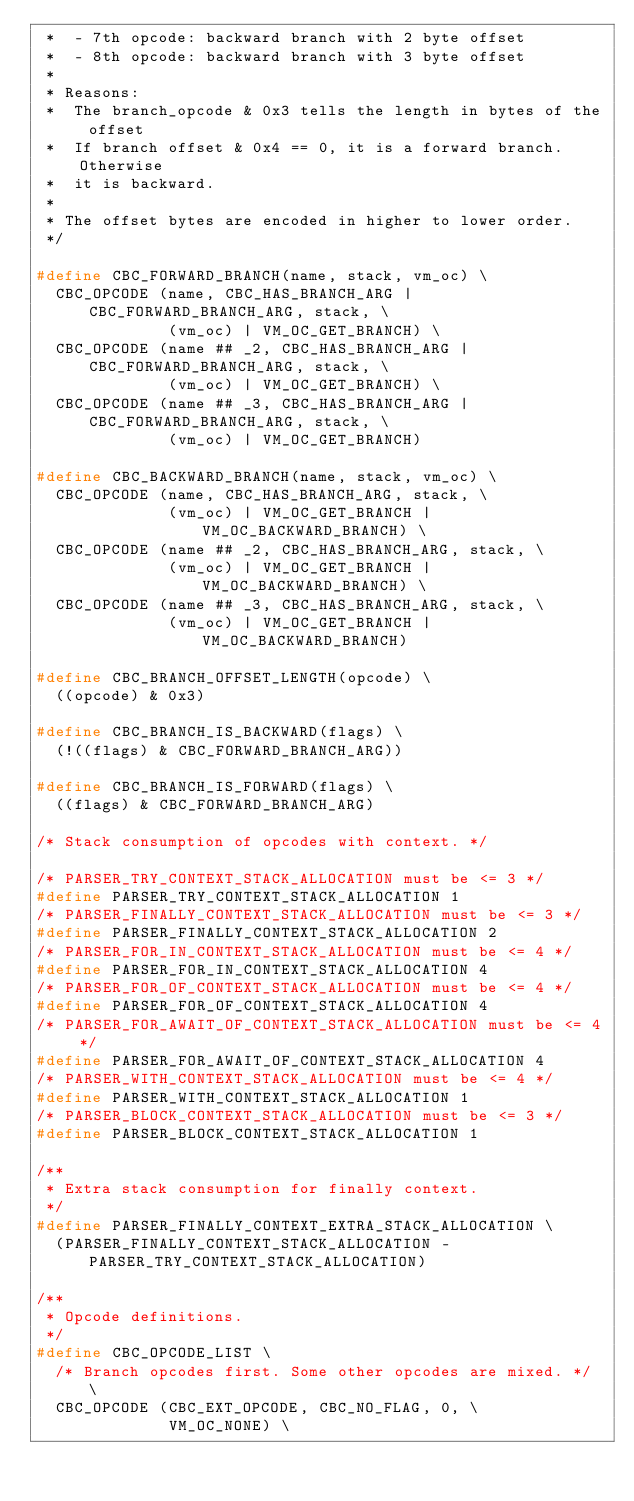<code> <loc_0><loc_0><loc_500><loc_500><_C_> *  - 7th opcode: backward branch with 2 byte offset
 *  - 8th opcode: backward branch with 3 byte offset
 *
 * Reasons:
 *  The branch_opcode & 0x3 tells the length in bytes of the offset
 *  If branch offset & 0x4 == 0, it is a forward branch. Otherwise
 *  it is backward.
 *
 * The offset bytes are encoded in higher to lower order.
 */

#define CBC_FORWARD_BRANCH(name, stack, vm_oc) \
  CBC_OPCODE (name, CBC_HAS_BRANCH_ARG | CBC_FORWARD_BRANCH_ARG, stack, \
              (vm_oc) | VM_OC_GET_BRANCH) \
  CBC_OPCODE (name ## _2, CBC_HAS_BRANCH_ARG | CBC_FORWARD_BRANCH_ARG, stack, \
              (vm_oc) | VM_OC_GET_BRANCH) \
  CBC_OPCODE (name ## _3, CBC_HAS_BRANCH_ARG | CBC_FORWARD_BRANCH_ARG, stack, \
              (vm_oc) | VM_OC_GET_BRANCH)

#define CBC_BACKWARD_BRANCH(name, stack, vm_oc) \
  CBC_OPCODE (name, CBC_HAS_BRANCH_ARG, stack, \
              (vm_oc) | VM_OC_GET_BRANCH | VM_OC_BACKWARD_BRANCH) \
  CBC_OPCODE (name ## _2, CBC_HAS_BRANCH_ARG, stack, \
              (vm_oc) | VM_OC_GET_BRANCH | VM_OC_BACKWARD_BRANCH) \
  CBC_OPCODE (name ## _3, CBC_HAS_BRANCH_ARG, stack, \
              (vm_oc) | VM_OC_GET_BRANCH | VM_OC_BACKWARD_BRANCH)

#define CBC_BRANCH_OFFSET_LENGTH(opcode) \
  ((opcode) & 0x3)

#define CBC_BRANCH_IS_BACKWARD(flags) \
  (!((flags) & CBC_FORWARD_BRANCH_ARG))

#define CBC_BRANCH_IS_FORWARD(flags) \
  ((flags) & CBC_FORWARD_BRANCH_ARG)

/* Stack consumption of opcodes with context. */

/* PARSER_TRY_CONTEXT_STACK_ALLOCATION must be <= 3 */
#define PARSER_TRY_CONTEXT_STACK_ALLOCATION 1
/* PARSER_FINALLY_CONTEXT_STACK_ALLOCATION must be <= 3 */
#define PARSER_FINALLY_CONTEXT_STACK_ALLOCATION 2
/* PARSER_FOR_IN_CONTEXT_STACK_ALLOCATION must be <= 4 */
#define PARSER_FOR_IN_CONTEXT_STACK_ALLOCATION 4
/* PARSER_FOR_OF_CONTEXT_STACK_ALLOCATION must be <= 4 */
#define PARSER_FOR_OF_CONTEXT_STACK_ALLOCATION 4
/* PARSER_FOR_AWAIT_OF_CONTEXT_STACK_ALLOCATION must be <= 4 */
#define PARSER_FOR_AWAIT_OF_CONTEXT_STACK_ALLOCATION 4
/* PARSER_WITH_CONTEXT_STACK_ALLOCATION must be <= 4 */
#define PARSER_WITH_CONTEXT_STACK_ALLOCATION 1
/* PARSER_BLOCK_CONTEXT_STACK_ALLOCATION must be <= 3 */
#define PARSER_BLOCK_CONTEXT_STACK_ALLOCATION 1

/**
 * Extra stack consumption for finally context.
 */
#define PARSER_FINALLY_CONTEXT_EXTRA_STACK_ALLOCATION \
  (PARSER_FINALLY_CONTEXT_STACK_ALLOCATION - PARSER_TRY_CONTEXT_STACK_ALLOCATION)

/**
 * Opcode definitions.
 */
#define CBC_OPCODE_LIST \
  /* Branch opcodes first. Some other opcodes are mixed. */ \
  CBC_OPCODE (CBC_EXT_OPCODE, CBC_NO_FLAG, 0, \
              VM_OC_NONE) \</code> 